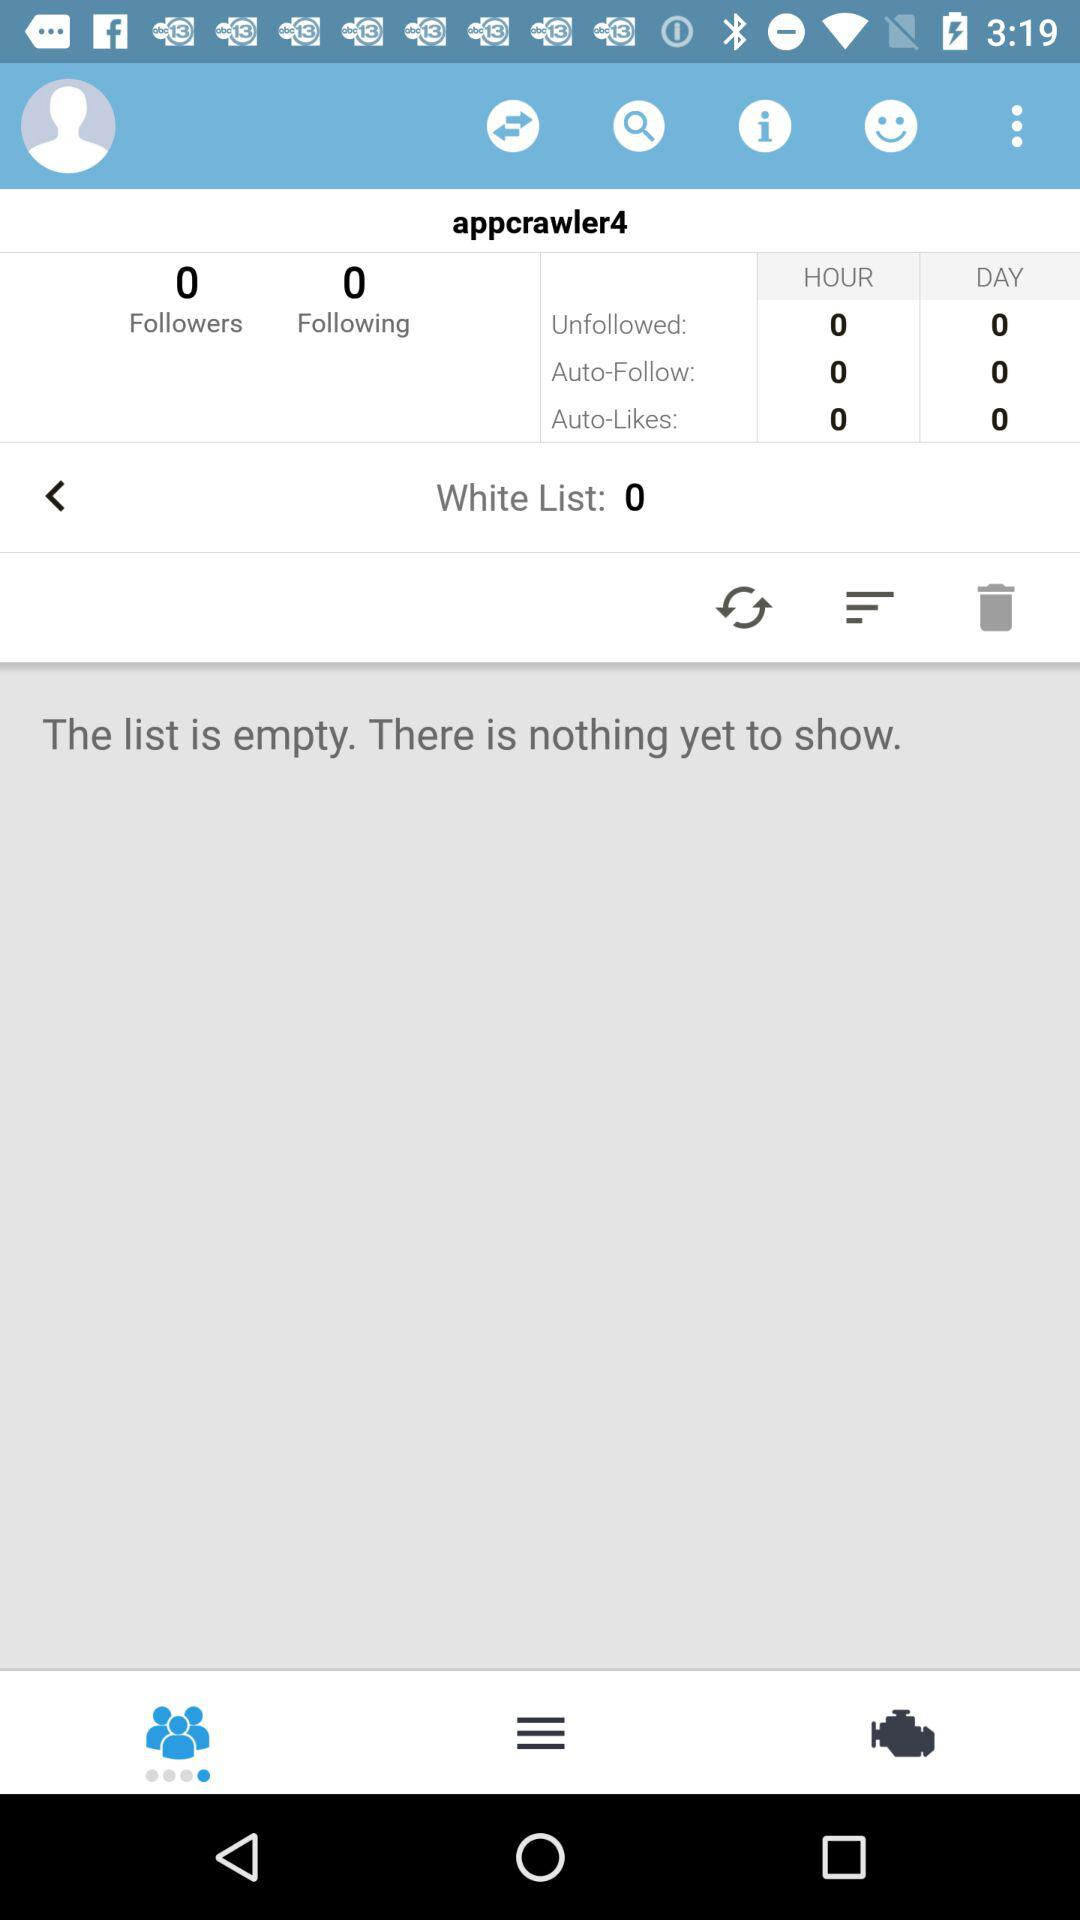How many people is "appcrawler4" following? "appcrawler4" is following 0 people. 